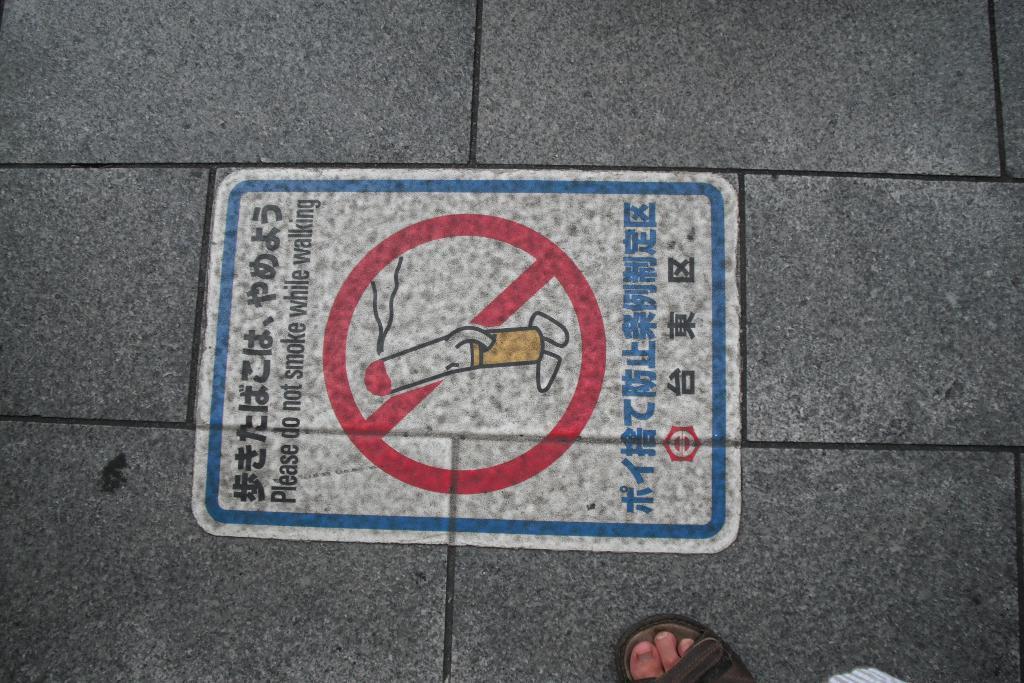Please provide a concise description of this image. In this picture we can see there is a sign board on the floor and we can see a person leg on the floor. 